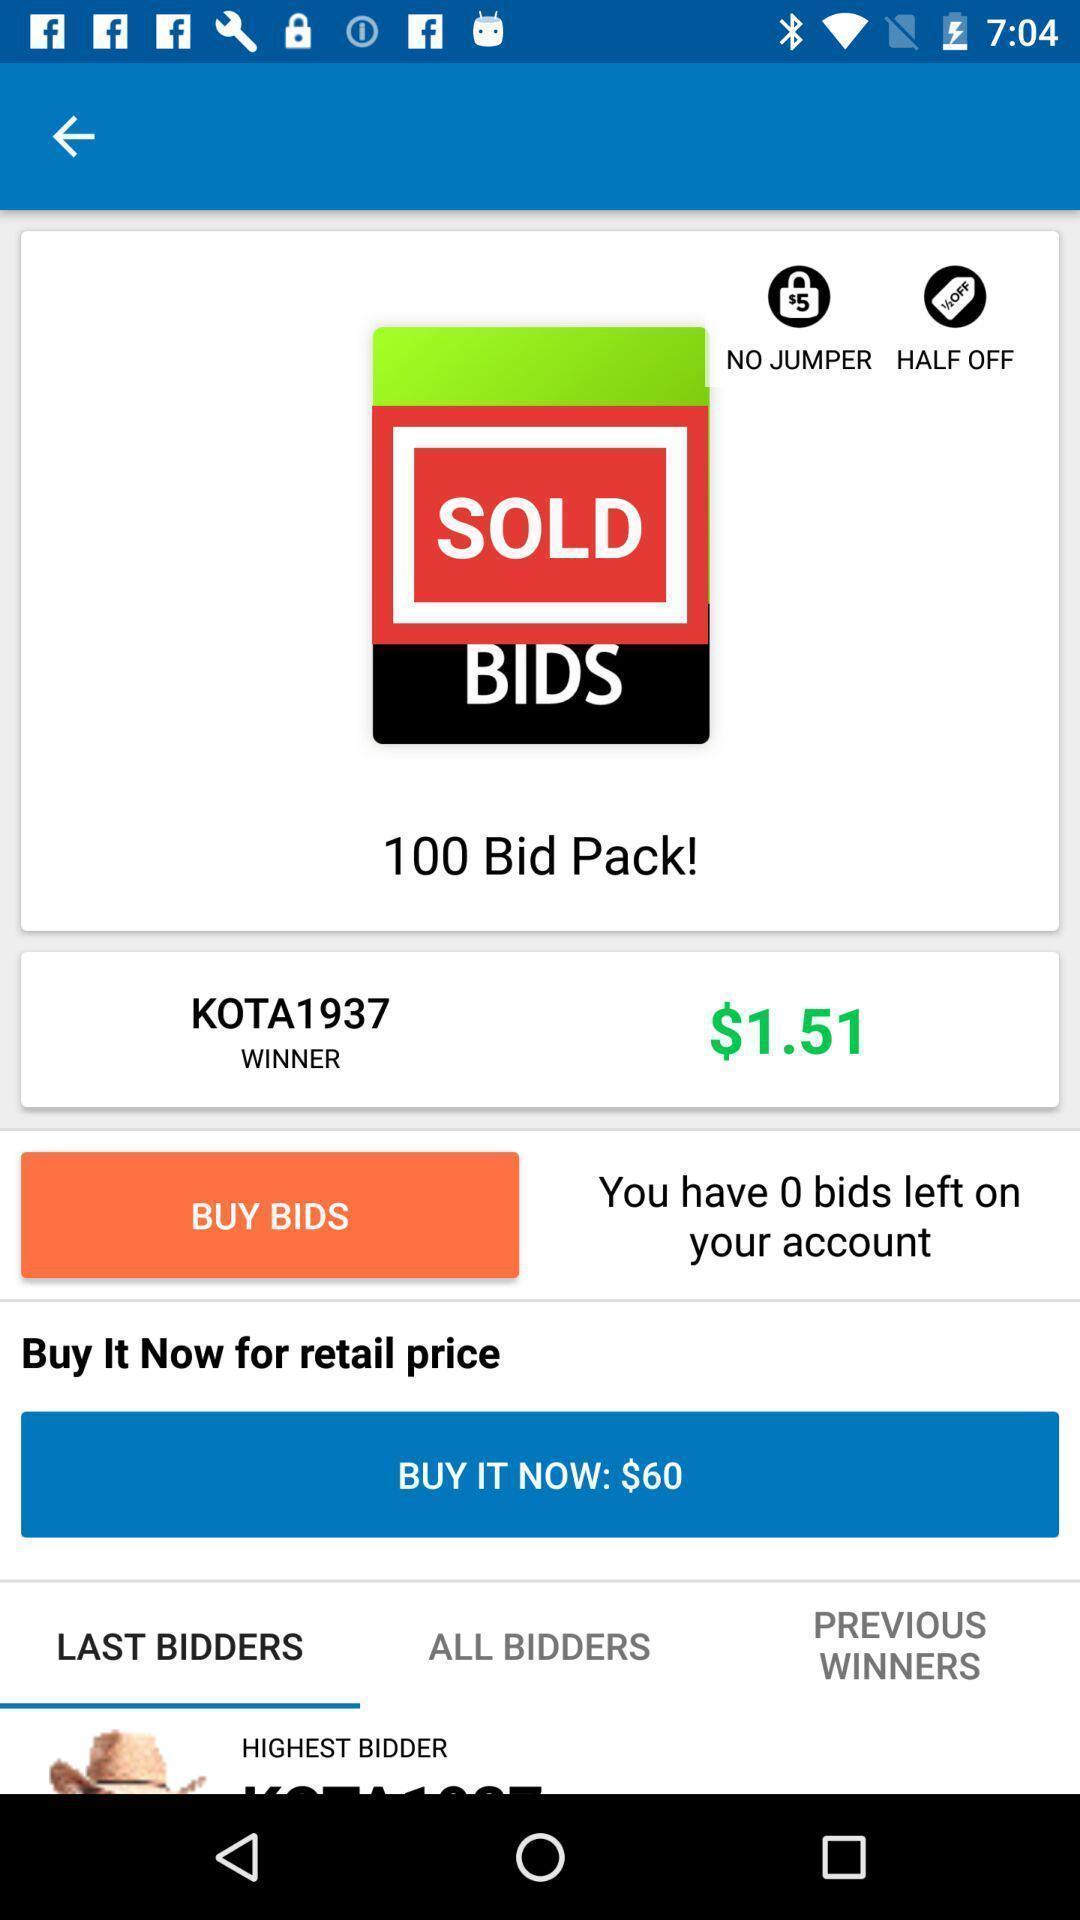Please provide a description for this image. Purchasing page of a bid pack. 